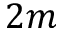Convert formula to latex. <formula><loc_0><loc_0><loc_500><loc_500>2 m</formula> 